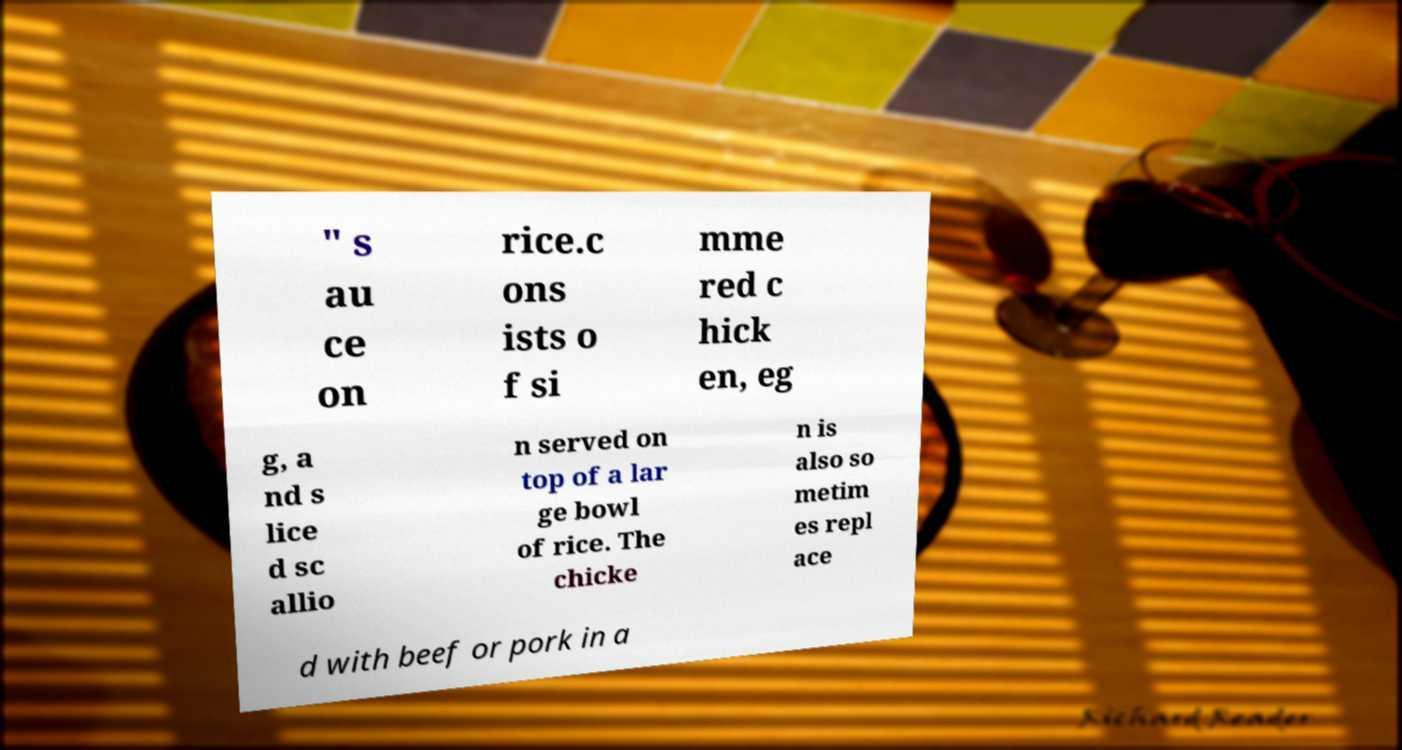Can you read and provide the text displayed in the image?This photo seems to have some interesting text. Can you extract and type it out for me? " s au ce on rice.c ons ists o f si mme red c hick en, eg g, a nd s lice d sc allio n served on top of a lar ge bowl of rice. The chicke n is also so metim es repl ace d with beef or pork in a 